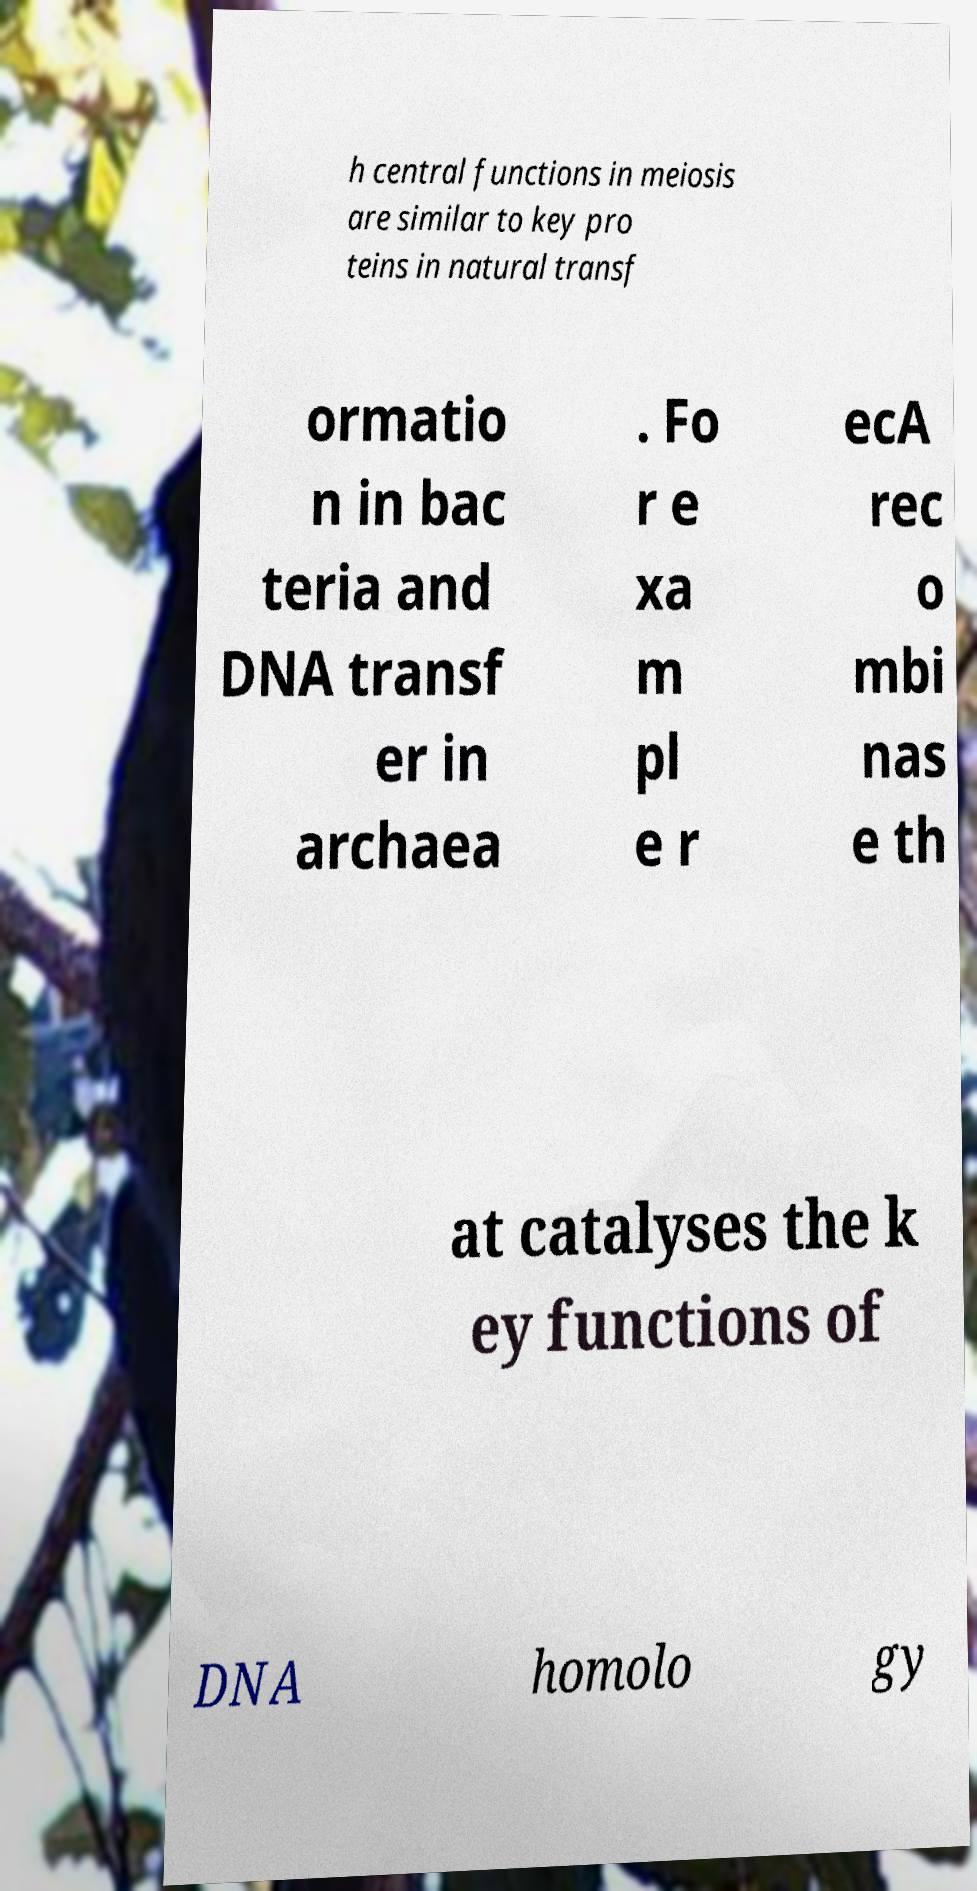Can you read and provide the text displayed in the image?This photo seems to have some interesting text. Can you extract and type it out for me? h central functions in meiosis are similar to key pro teins in natural transf ormatio n in bac teria and DNA transf er in archaea . Fo r e xa m pl e r ecA rec o mbi nas e th at catalyses the k ey functions of DNA homolo gy 